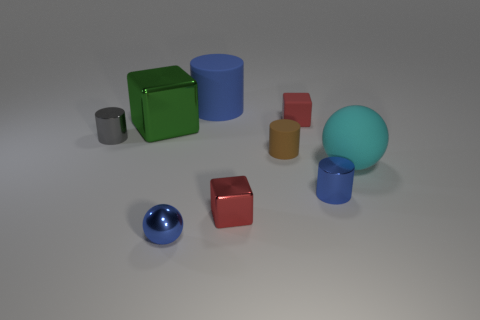Subtract all red cylinders. Subtract all purple blocks. How many cylinders are left? 4 Add 1 tiny matte cubes. How many objects exist? 10 Subtract all blocks. How many objects are left? 6 Subtract 0 cyan cylinders. How many objects are left? 9 Subtract all cubes. Subtract all tiny blue spheres. How many objects are left? 5 Add 4 small metal spheres. How many small metal spheres are left? 5 Add 9 big brown shiny spheres. How many big brown shiny spheres exist? 9 